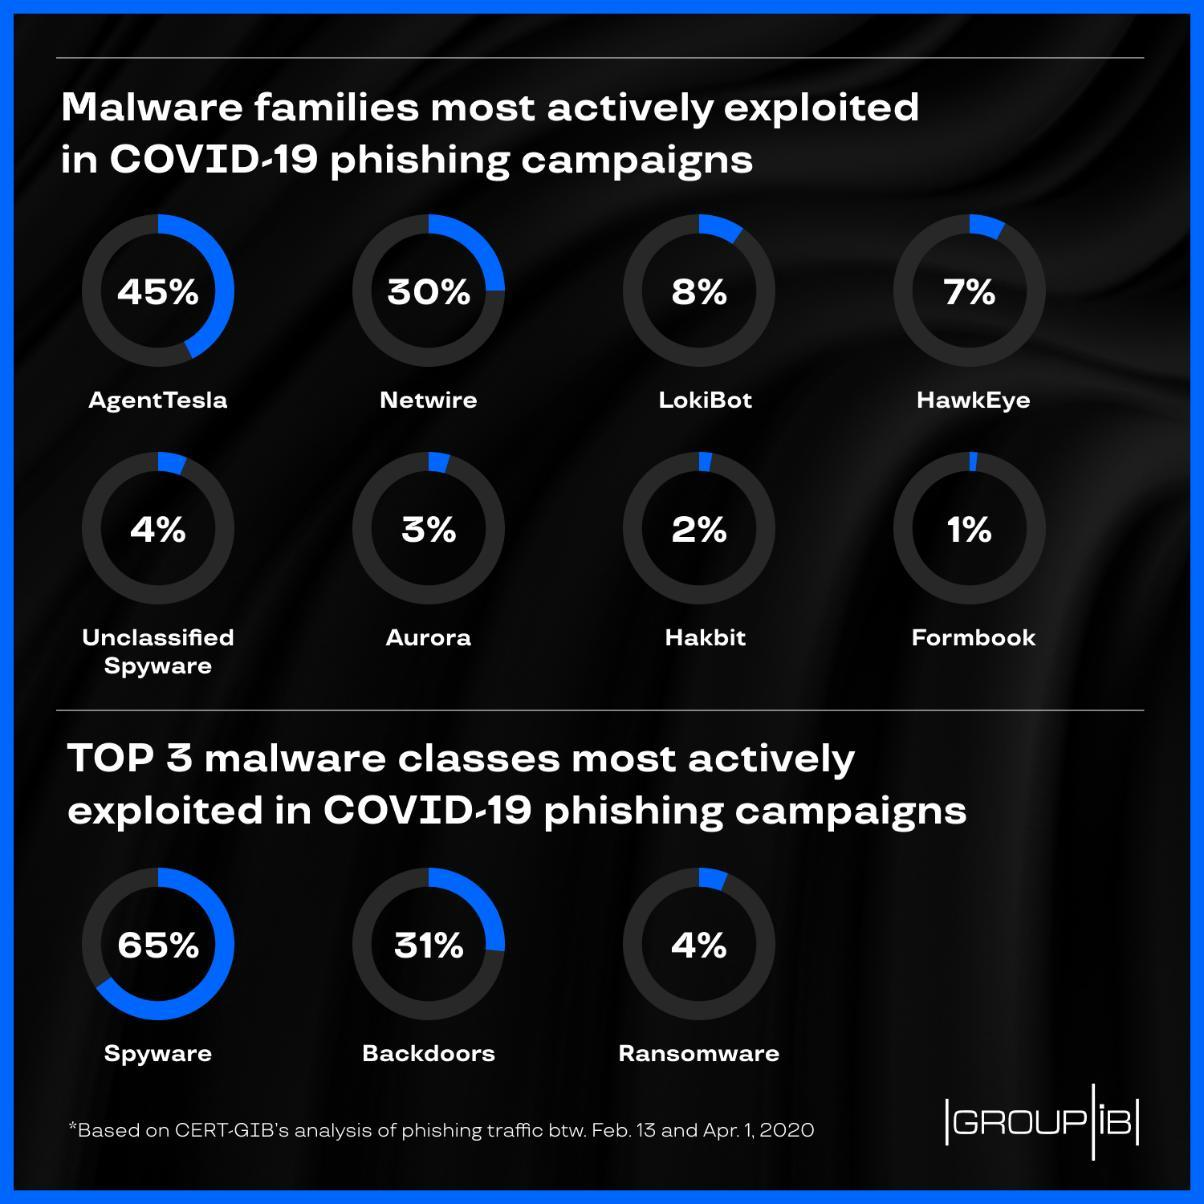Which is the second most actively exploited malware family in covid-19 phishing campaigns?
Answer the question with a short phrase. Netwire Which is the most actively exploited malware family in covid-19 phishing campaigns? AgentTesla Which is the most actively exploited malware classes in covid-19 phishing campaigns? Spyware Which is the least actively exploited malware family in covid-19 phishing campaigns? Formbook 